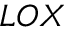Convert formula to latex. <formula><loc_0><loc_0><loc_500><loc_500>L O X</formula> 